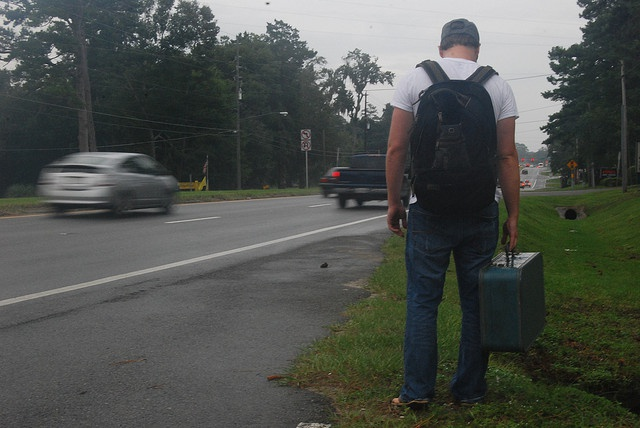Describe the objects in this image and their specific colors. I can see people in gray, black, maroon, and darkgray tones, backpack in gray, black, and darkblue tones, car in gray, black, darkgray, and purple tones, suitcase in gray, black, purple, and darkgray tones, and car in gray and black tones in this image. 